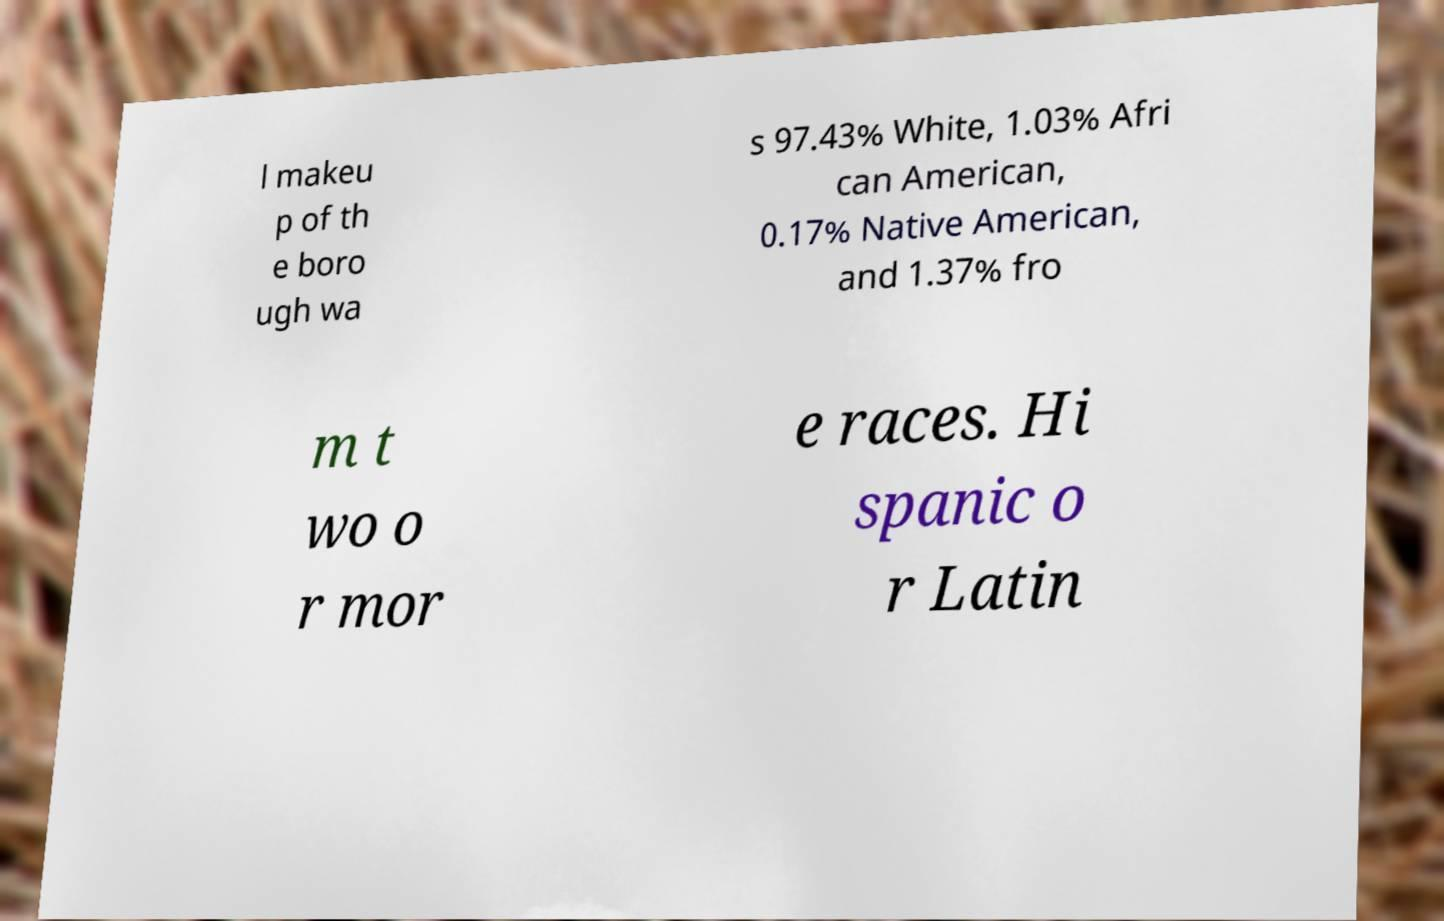Can you accurately transcribe the text from the provided image for me? l makeu p of th e boro ugh wa s 97.43% White, 1.03% Afri can American, 0.17% Native American, and 1.37% fro m t wo o r mor e races. Hi spanic o r Latin 